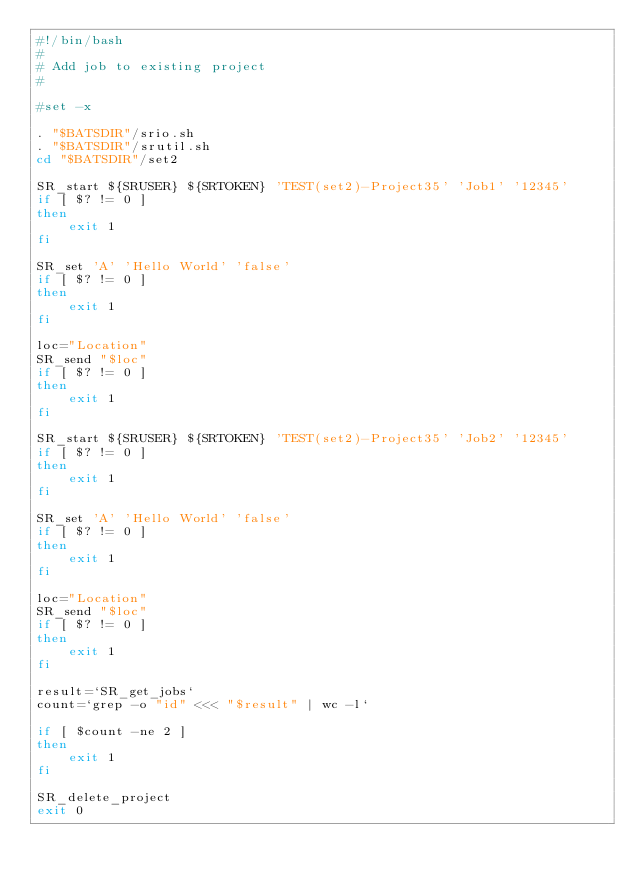<code> <loc_0><loc_0><loc_500><loc_500><_Bash_>#!/bin/bash
#
# Add job to existing project
#

#set -x

. "$BATSDIR"/srio.sh
. "$BATSDIR"/srutil.sh
cd "$BATSDIR"/set2

SR_start ${SRUSER} ${SRTOKEN} 'TEST(set2)-Project35' 'Job1' '12345'
if [ $? != 0 ]
then
    exit 1
fi

SR_set 'A' 'Hello World' 'false'
if [ $? != 0 ]
then
    exit 1
fi

loc="Location"
SR_send "$loc"
if [ $? != 0 ]
then
    exit 1
fi

SR_start ${SRUSER} ${SRTOKEN} 'TEST(set2)-Project35' 'Job2' '12345'
if [ $? != 0 ]
then
    exit 1
fi

SR_set 'A' 'Hello World' 'false'
if [ $? != 0 ]
then
    exit 1
fi

loc="Location"
SR_send "$loc"
if [ $? != 0 ]
then
    exit 1
fi

result=`SR_get_jobs`
count=`grep -o "id" <<< "$result" | wc -l`

if [ $count -ne 2 ]
then
    exit 1
fi

SR_delete_project
exit 0


</code> 